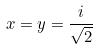Convert formula to latex. <formula><loc_0><loc_0><loc_500><loc_500>x = y = \frac { i } { \sqrt { 2 } }</formula> 